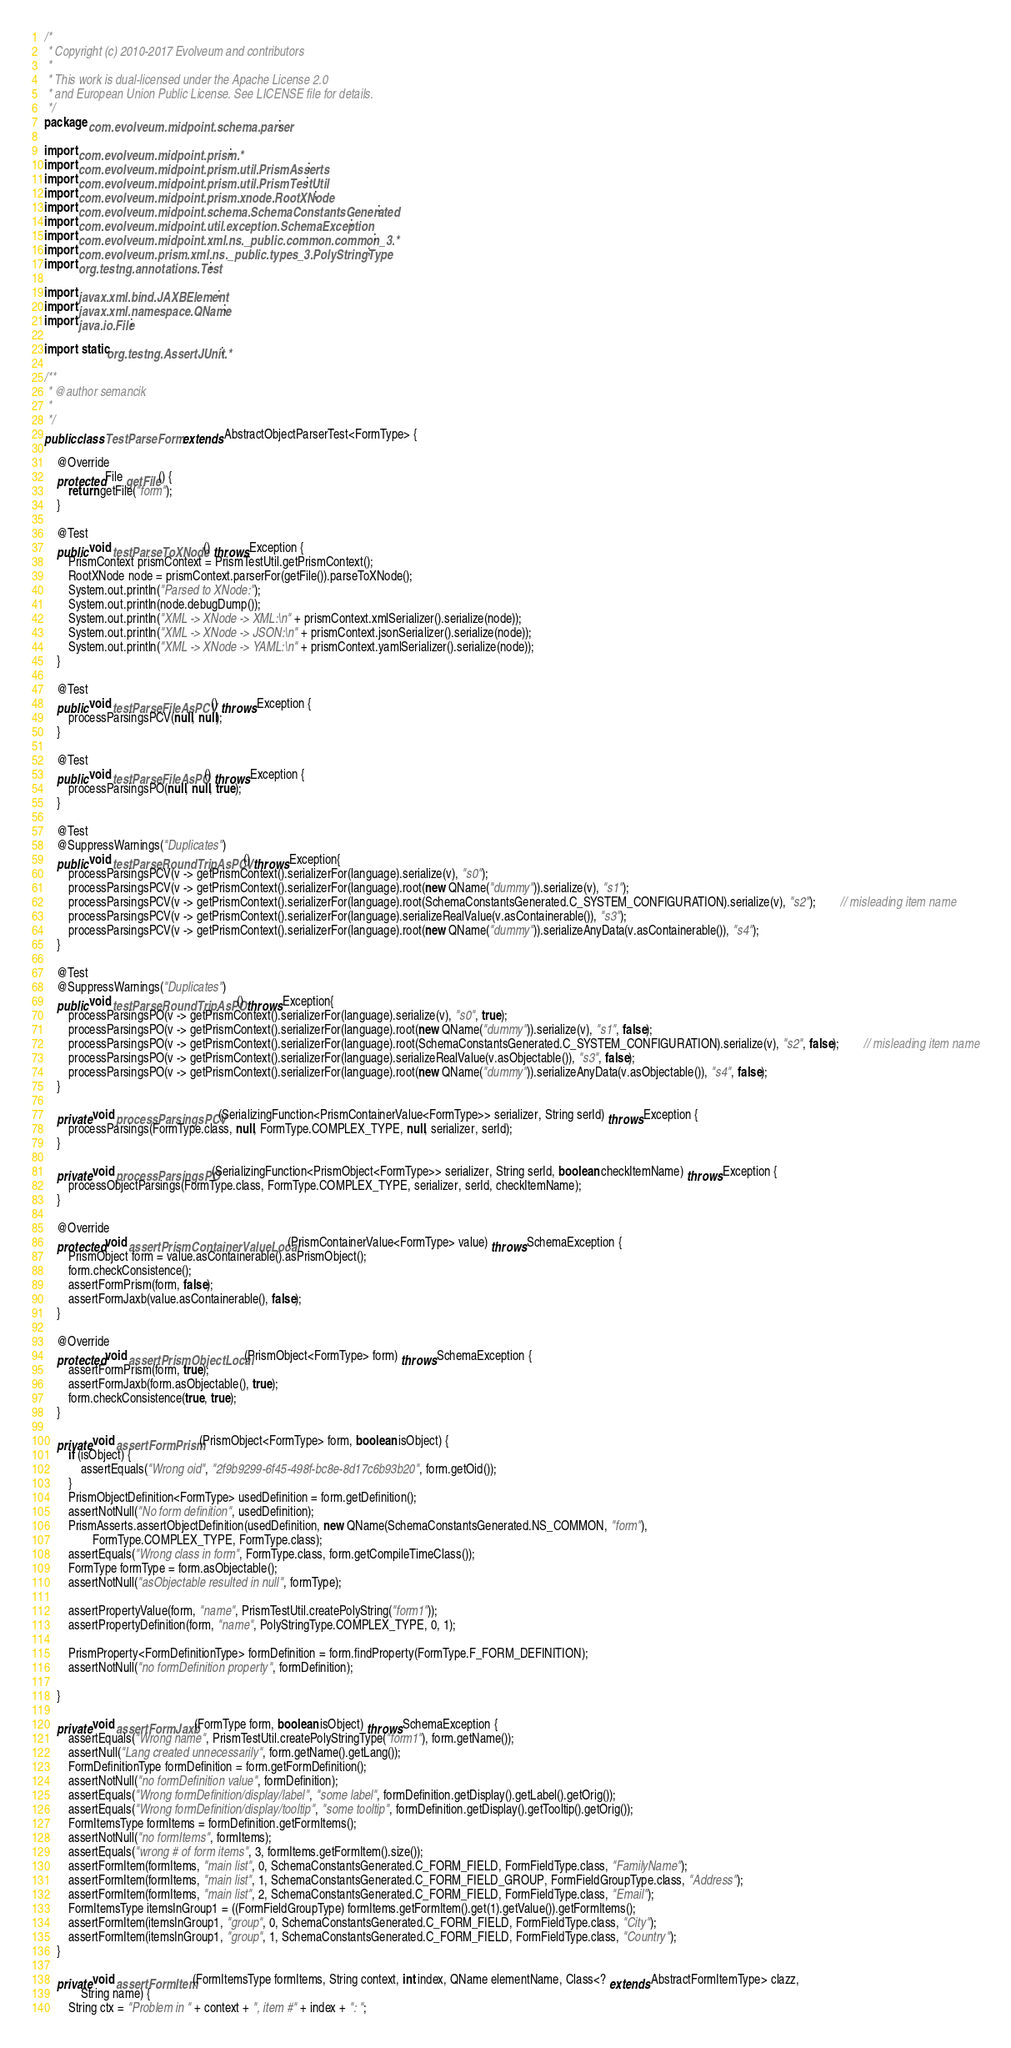Convert code to text. <code><loc_0><loc_0><loc_500><loc_500><_Java_>/*
 * Copyright (c) 2010-2017 Evolveum and contributors
 *
 * This work is dual-licensed under the Apache License 2.0
 * and European Union Public License. See LICENSE file for details.
 */
package com.evolveum.midpoint.schema.parser;

import com.evolveum.midpoint.prism.*;
import com.evolveum.midpoint.prism.util.PrismAsserts;
import com.evolveum.midpoint.prism.util.PrismTestUtil;
import com.evolveum.midpoint.prism.xnode.RootXNode;
import com.evolveum.midpoint.schema.SchemaConstantsGenerated;
import com.evolveum.midpoint.util.exception.SchemaException;
import com.evolveum.midpoint.xml.ns._public.common.common_3.*;
import com.evolveum.prism.xml.ns._public.types_3.PolyStringType;
import org.testng.annotations.Test;

import javax.xml.bind.JAXBElement;
import javax.xml.namespace.QName;
import java.io.File;

import static org.testng.AssertJUnit.*;

/**
 * @author semancik
 *
 */
public class TestParseForm extends AbstractObjectParserTest<FormType> {

    @Override
    protected File getFile() {
        return getFile("form");
    }

    @Test
    public void testParseToXNode() throws Exception {
        PrismContext prismContext = PrismTestUtil.getPrismContext();
        RootXNode node = prismContext.parserFor(getFile()).parseToXNode();
        System.out.println("Parsed to XNode:");
        System.out.println(node.debugDump());
        System.out.println("XML -> XNode -> XML:\n" + prismContext.xmlSerializer().serialize(node));
        System.out.println("XML -> XNode -> JSON:\n" + prismContext.jsonSerializer().serialize(node));
        System.out.println("XML -> XNode -> YAML:\n" + prismContext.yamlSerializer().serialize(node));
    }

    @Test
    public void testParseFileAsPCV() throws Exception {
        processParsingsPCV(null, null);
    }

    @Test
    public void testParseFileAsPO() throws Exception {
        processParsingsPO(null, null, true);
    }

    @Test
    @SuppressWarnings("Duplicates")
    public void testParseRoundTripAsPCV() throws Exception{
        processParsingsPCV(v -> getPrismContext().serializerFor(language).serialize(v), "s0");
        processParsingsPCV(v -> getPrismContext().serializerFor(language).root(new QName("dummy")).serialize(v), "s1");
        processParsingsPCV(v -> getPrismContext().serializerFor(language).root(SchemaConstantsGenerated.C_SYSTEM_CONFIGURATION).serialize(v), "s2");        // misleading item name
        processParsingsPCV(v -> getPrismContext().serializerFor(language).serializeRealValue(v.asContainerable()), "s3");
        processParsingsPCV(v -> getPrismContext().serializerFor(language).root(new QName("dummy")).serializeAnyData(v.asContainerable()), "s4");
    }

    @Test
    @SuppressWarnings("Duplicates")
    public void testParseRoundTripAsPO() throws Exception{
        processParsingsPO(v -> getPrismContext().serializerFor(language).serialize(v), "s0", true);
        processParsingsPO(v -> getPrismContext().serializerFor(language).root(new QName("dummy")).serialize(v), "s1", false);
        processParsingsPO(v -> getPrismContext().serializerFor(language).root(SchemaConstantsGenerated.C_SYSTEM_CONFIGURATION).serialize(v), "s2", false);        // misleading item name
        processParsingsPO(v -> getPrismContext().serializerFor(language).serializeRealValue(v.asObjectable()), "s3", false);
        processParsingsPO(v -> getPrismContext().serializerFor(language).root(new QName("dummy")).serializeAnyData(v.asObjectable()), "s4", false);
    }

    private void processParsingsPCV(SerializingFunction<PrismContainerValue<FormType>> serializer, String serId) throws Exception {
        processParsings(FormType.class, null, FormType.COMPLEX_TYPE, null, serializer, serId);
    }

    private void processParsingsPO(SerializingFunction<PrismObject<FormType>> serializer, String serId, boolean checkItemName) throws Exception {
        processObjectParsings(FormType.class, FormType.COMPLEX_TYPE, serializer, serId, checkItemName);
    }

    @Override
    protected void assertPrismContainerValueLocal(PrismContainerValue<FormType> value) throws SchemaException {
        PrismObject form = value.asContainerable().asPrismObject();
        form.checkConsistence();
        assertFormPrism(form, false);
        assertFormJaxb(value.asContainerable(), false);
    }

    @Override
    protected void assertPrismObjectLocal(PrismObject<FormType> form) throws SchemaException {
        assertFormPrism(form, true);
        assertFormJaxb(form.asObjectable(), true);
        form.checkConsistence(true, true);
    }

    private void assertFormPrism(PrismObject<FormType> form, boolean isObject) {
        if (isObject) {
            assertEquals("Wrong oid", "2f9b9299-6f45-498f-bc8e-8d17c6b93b20", form.getOid());
        }
        PrismObjectDefinition<FormType> usedDefinition = form.getDefinition();
        assertNotNull("No form definition", usedDefinition);
        PrismAsserts.assertObjectDefinition(usedDefinition, new QName(SchemaConstantsGenerated.NS_COMMON, "form"),
                FormType.COMPLEX_TYPE, FormType.class);
        assertEquals("Wrong class in form", FormType.class, form.getCompileTimeClass());
        FormType formType = form.asObjectable();
        assertNotNull("asObjectable resulted in null", formType);

        assertPropertyValue(form, "name", PrismTestUtil.createPolyString("form1"));
        assertPropertyDefinition(form, "name", PolyStringType.COMPLEX_TYPE, 0, 1);

        PrismProperty<FormDefinitionType> formDefinition = form.findProperty(FormType.F_FORM_DEFINITION);
        assertNotNull("no formDefinition property", formDefinition);

    }

    private void assertFormJaxb(FormType form, boolean isObject) throws SchemaException {
        assertEquals("Wrong name", PrismTestUtil.createPolyStringType("form1"), form.getName());
        assertNull("Lang created unnecessarily", form.getName().getLang());
        FormDefinitionType formDefinition = form.getFormDefinition();
        assertNotNull("no formDefinition value", formDefinition);
        assertEquals("Wrong formDefinition/display/label", "some label", formDefinition.getDisplay().getLabel().getOrig());
        assertEquals("Wrong formDefinition/display/tooltip", "some tooltip", formDefinition.getDisplay().getTooltip().getOrig());
        FormItemsType formItems = formDefinition.getFormItems();
        assertNotNull("no formItems", formItems);
        assertEquals("wrong # of form items", 3, formItems.getFormItem().size());
        assertFormItem(formItems, "main list", 0, SchemaConstantsGenerated.C_FORM_FIELD, FormFieldType.class, "FamilyName");
        assertFormItem(formItems, "main list", 1, SchemaConstantsGenerated.C_FORM_FIELD_GROUP, FormFieldGroupType.class, "Address");
        assertFormItem(formItems, "main list", 2, SchemaConstantsGenerated.C_FORM_FIELD, FormFieldType.class, "Email");
        FormItemsType itemsInGroup1 = ((FormFieldGroupType) formItems.getFormItem().get(1).getValue()).getFormItems();
        assertFormItem(itemsInGroup1, "group", 0, SchemaConstantsGenerated.C_FORM_FIELD, FormFieldType.class, "City");
        assertFormItem(itemsInGroup1, "group", 1, SchemaConstantsGenerated.C_FORM_FIELD, FormFieldType.class, "Country");
    }

    private void assertFormItem(FormItemsType formItems, String context, int index, QName elementName, Class<? extends AbstractFormItemType> clazz,
            String name) {
        String ctx = "Problem in " + context + ", item #" + index + ": ";</code> 